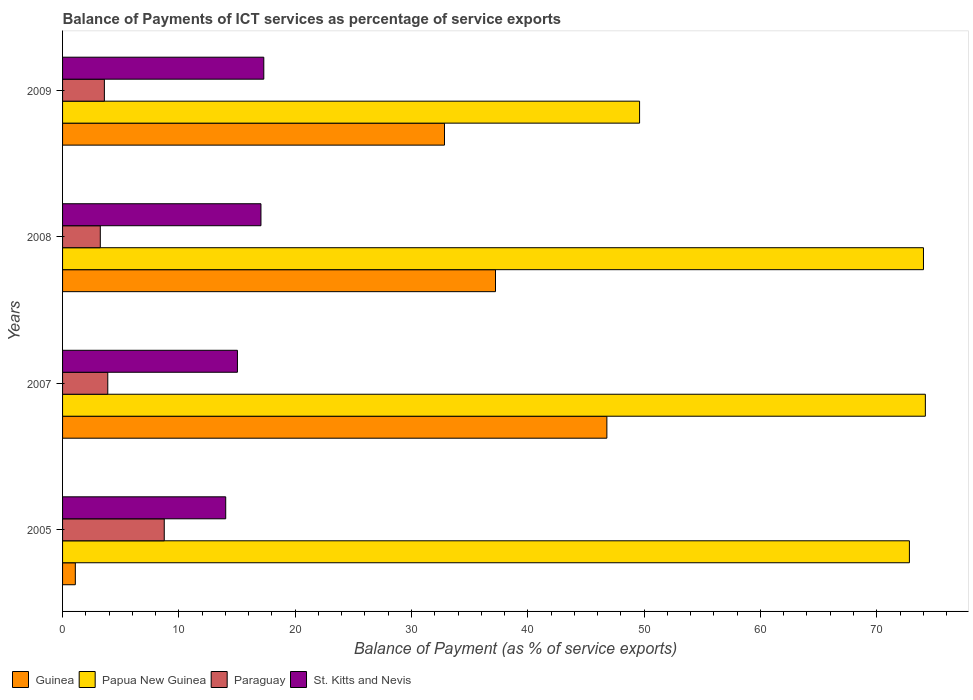How many groups of bars are there?
Your response must be concise. 4. Are the number of bars per tick equal to the number of legend labels?
Your answer should be very brief. Yes. How many bars are there on the 3rd tick from the top?
Offer a very short reply. 4. What is the label of the 2nd group of bars from the top?
Your answer should be very brief. 2008. In how many cases, is the number of bars for a given year not equal to the number of legend labels?
Your answer should be very brief. 0. What is the balance of payments of ICT services in Paraguay in 2005?
Keep it short and to the point. 8.74. Across all years, what is the maximum balance of payments of ICT services in Guinea?
Your answer should be very brief. 46.8. Across all years, what is the minimum balance of payments of ICT services in Paraguay?
Your answer should be compact. 3.24. In which year was the balance of payments of ICT services in Paraguay minimum?
Provide a succinct answer. 2008. What is the total balance of payments of ICT services in Papua New Guinea in the graph?
Make the answer very short. 270.61. What is the difference between the balance of payments of ICT services in Paraguay in 2008 and that in 2009?
Offer a terse response. -0.35. What is the difference between the balance of payments of ICT services in Papua New Guinea in 2005 and the balance of payments of ICT services in Guinea in 2009?
Keep it short and to the point. 39.97. What is the average balance of payments of ICT services in Paraguay per year?
Your answer should be compact. 4.87. In the year 2008, what is the difference between the balance of payments of ICT services in Guinea and balance of payments of ICT services in St. Kitts and Nevis?
Your answer should be very brief. 20.16. What is the ratio of the balance of payments of ICT services in Paraguay in 2008 to that in 2009?
Provide a succinct answer. 0.9. What is the difference between the highest and the second highest balance of payments of ICT services in Paraguay?
Your answer should be compact. 4.86. What is the difference between the highest and the lowest balance of payments of ICT services in St. Kitts and Nevis?
Keep it short and to the point. 3.27. What does the 3rd bar from the top in 2007 represents?
Keep it short and to the point. Papua New Guinea. What does the 2nd bar from the bottom in 2007 represents?
Your answer should be very brief. Papua New Guinea. How many bars are there?
Make the answer very short. 16. Are all the bars in the graph horizontal?
Offer a terse response. Yes. How many years are there in the graph?
Give a very brief answer. 4. Does the graph contain any zero values?
Give a very brief answer. No. How are the legend labels stacked?
Ensure brevity in your answer.  Horizontal. What is the title of the graph?
Your answer should be very brief. Balance of Payments of ICT services as percentage of service exports. Does "Saudi Arabia" appear as one of the legend labels in the graph?
Ensure brevity in your answer.  No. What is the label or title of the X-axis?
Offer a terse response. Balance of Payment (as % of service exports). What is the label or title of the Y-axis?
Keep it short and to the point. Years. What is the Balance of Payment (as % of service exports) of Guinea in 2005?
Give a very brief answer. 1.1. What is the Balance of Payment (as % of service exports) in Papua New Guinea in 2005?
Make the answer very short. 72.81. What is the Balance of Payment (as % of service exports) in Paraguay in 2005?
Keep it short and to the point. 8.74. What is the Balance of Payment (as % of service exports) of St. Kitts and Nevis in 2005?
Provide a succinct answer. 14.03. What is the Balance of Payment (as % of service exports) of Guinea in 2007?
Offer a very short reply. 46.8. What is the Balance of Payment (as % of service exports) in Papua New Guinea in 2007?
Keep it short and to the point. 74.18. What is the Balance of Payment (as % of service exports) in Paraguay in 2007?
Your answer should be very brief. 3.89. What is the Balance of Payment (as % of service exports) of St. Kitts and Nevis in 2007?
Your answer should be very brief. 15.03. What is the Balance of Payment (as % of service exports) of Guinea in 2008?
Give a very brief answer. 37.22. What is the Balance of Payment (as % of service exports) of Papua New Guinea in 2008?
Make the answer very short. 74.02. What is the Balance of Payment (as % of service exports) of Paraguay in 2008?
Make the answer very short. 3.24. What is the Balance of Payment (as % of service exports) in St. Kitts and Nevis in 2008?
Provide a succinct answer. 17.06. What is the Balance of Payment (as % of service exports) of Guinea in 2009?
Provide a succinct answer. 32.83. What is the Balance of Payment (as % of service exports) in Papua New Guinea in 2009?
Provide a short and direct response. 49.61. What is the Balance of Payment (as % of service exports) in Paraguay in 2009?
Keep it short and to the point. 3.59. What is the Balance of Payment (as % of service exports) of St. Kitts and Nevis in 2009?
Ensure brevity in your answer.  17.3. Across all years, what is the maximum Balance of Payment (as % of service exports) of Guinea?
Ensure brevity in your answer.  46.8. Across all years, what is the maximum Balance of Payment (as % of service exports) in Papua New Guinea?
Ensure brevity in your answer.  74.18. Across all years, what is the maximum Balance of Payment (as % of service exports) of Paraguay?
Provide a succinct answer. 8.74. Across all years, what is the maximum Balance of Payment (as % of service exports) in St. Kitts and Nevis?
Make the answer very short. 17.3. Across all years, what is the minimum Balance of Payment (as % of service exports) of Guinea?
Your answer should be compact. 1.1. Across all years, what is the minimum Balance of Payment (as % of service exports) of Papua New Guinea?
Offer a terse response. 49.61. Across all years, what is the minimum Balance of Payment (as % of service exports) in Paraguay?
Your response must be concise. 3.24. Across all years, what is the minimum Balance of Payment (as % of service exports) of St. Kitts and Nevis?
Offer a terse response. 14.03. What is the total Balance of Payment (as % of service exports) of Guinea in the graph?
Offer a terse response. 117.95. What is the total Balance of Payment (as % of service exports) of Papua New Guinea in the graph?
Keep it short and to the point. 270.61. What is the total Balance of Payment (as % of service exports) in Paraguay in the graph?
Provide a short and direct response. 19.47. What is the total Balance of Payment (as % of service exports) of St. Kitts and Nevis in the graph?
Keep it short and to the point. 63.42. What is the difference between the Balance of Payment (as % of service exports) in Guinea in 2005 and that in 2007?
Ensure brevity in your answer.  -45.7. What is the difference between the Balance of Payment (as % of service exports) in Papua New Guinea in 2005 and that in 2007?
Keep it short and to the point. -1.37. What is the difference between the Balance of Payment (as % of service exports) in Paraguay in 2005 and that in 2007?
Keep it short and to the point. 4.86. What is the difference between the Balance of Payment (as % of service exports) of St. Kitts and Nevis in 2005 and that in 2007?
Make the answer very short. -1.01. What is the difference between the Balance of Payment (as % of service exports) in Guinea in 2005 and that in 2008?
Offer a terse response. -36.12. What is the difference between the Balance of Payment (as % of service exports) in Papua New Guinea in 2005 and that in 2008?
Ensure brevity in your answer.  -1.21. What is the difference between the Balance of Payment (as % of service exports) of Paraguay in 2005 and that in 2008?
Offer a terse response. 5.5. What is the difference between the Balance of Payment (as % of service exports) of St. Kitts and Nevis in 2005 and that in 2008?
Offer a very short reply. -3.03. What is the difference between the Balance of Payment (as % of service exports) in Guinea in 2005 and that in 2009?
Your response must be concise. -31.74. What is the difference between the Balance of Payment (as % of service exports) of Papua New Guinea in 2005 and that in 2009?
Give a very brief answer. 23.2. What is the difference between the Balance of Payment (as % of service exports) of Paraguay in 2005 and that in 2009?
Your answer should be very brief. 5.15. What is the difference between the Balance of Payment (as % of service exports) of St. Kitts and Nevis in 2005 and that in 2009?
Offer a terse response. -3.27. What is the difference between the Balance of Payment (as % of service exports) in Guinea in 2007 and that in 2008?
Give a very brief answer. 9.58. What is the difference between the Balance of Payment (as % of service exports) in Papua New Guinea in 2007 and that in 2008?
Your answer should be very brief. 0.16. What is the difference between the Balance of Payment (as % of service exports) in Paraguay in 2007 and that in 2008?
Keep it short and to the point. 0.64. What is the difference between the Balance of Payment (as % of service exports) of St. Kitts and Nevis in 2007 and that in 2008?
Ensure brevity in your answer.  -2.02. What is the difference between the Balance of Payment (as % of service exports) of Guinea in 2007 and that in 2009?
Offer a terse response. 13.96. What is the difference between the Balance of Payment (as % of service exports) of Papua New Guinea in 2007 and that in 2009?
Your answer should be compact. 24.57. What is the difference between the Balance of Payment (as % of service exports) of Paraguay in 2007 and that in 2009?
Ensure brevity in your answer.  0.29. What is the difference between the Balance of Payment (as % of service exports) in St. Kitts and Nevis in 2007 and that in 2009?
Keep it short and to the point. -2.27. What is the difference between the Balance of Payment (as % of service exports) of Guinea in 2008 and that in 2009?
Ensure brevity in your answer.  4.39. What is the difference between the Balance of Payment (as % of service exports) in Papua New Guinea in 2008 and that in 2009?
Keep it short and to the point. 24.41. What is the difference between the Balance of Payment (as % of service exports) of Paraguay in 2008 and that in 2009?
Offer a terse response. -0.35. What is the difference between the Balance of Payment (as % of service exports) of St. Kitts and Nevis in 2008 and that in 2009?
Make the answer very short. -0.24. What is the difference between the Balance of Payment (as % of service exports) in Guinea in 2005 and the Balance of Payment (as % of service exports) in Papua New Guinea in 2007?
Your answer should be very brief. -73.08. What is the difference between the Balance of Payment (as % of service exports) of Guinea in 2005 and the Balance of Payment (as % of service exports) of Paraguay in 2007?
Offer a terse response. -2.79. What is the difference between the Balance of Payment (as % of service exports) in Guinea in 2005 and the Balance of Payment (as % of service exports) in St. Kitts and Nevis in 2007?
Provide a short and direct response. -13.94. What is the difference between the Balance of Payment (as % of service exports) of Papua New Guinea in 2005 and the Balance of Payment (as % of service exports) of Paraguay in 2007?
Provide a short and direct response. 68.92. What is the difference between the Balance of Payment (as % of service exports) of Papua New Guinea in 2005 and the Balance of Payment (as % of service exports) of St. Kitts and Nevis in 2007?
Provide a succinct answer. 57.77. What is the difference between the Balance of Payment (as % of service exports) of Paraguay in 2005 and the Balance of Payment (as % of service exports) of St. Kitts and Nevis in 2007?
Make the answer very short. -6.29. What is the difference between the Balance of Payment (as % of service exports) in Guinea in 2005 and the Balance of Payment (as % of service exports) in Papua New Guinea in 2008?
Provide a succinct answer. -72.92. What is the difference between the Balance of Payment (as % of service exports) in Guinea in 2005 and the Balance of Payment (as % of service exports) in Paraguay in 2008?
Make the answer very short. -2.15. What is the difference between the Balance of Payment (as % of service exports) in Guinea in 2005 and the Balance of Payment (as % of service exports) in St. Kitts and Nevis in 2008?
Give a very brief answer. -15.96. What is the difference between the Balance of Payment (as % of service exports) in Papua New Guinea in 2005 and the Balance of Payment (as % of service exports) in Paraguay in 2008?
Offer a very short reply. 69.56. What is the difference between the Balance of Payment (as % of service exports) of Papua New Guinea in 2005 and the Balance of Payment (as % of service exports) of St. Kitts and Nevis in 2008?
Provide a succinct answer. 55.75. What is the difference between the Balance of Payment (as % of service exports) in Paraguay in 2005 and the Balance of Payment (as % of service exports) in St. Kitts and Nevis in 2008?
Your answer should be compact. -8.31. What is the difference between the Balance of Payment (as % of service exports) of Guinea in 2005 and the Balance of Payment (as % of service exports) of Papua New Guinea in 2009?
Provide a succinct answer. -48.51. What is the difference between the Balance of Payment (as % of service exports) of Guinea in 2005 and the Balance of Payment (as % of service exports) of Paraguay in 2009?
Keep it short and to the point. -2.5. What is the difference between the Balance of Payment (as % of service exports) in Guinea in 2005 and the Balance of Payment (as % of service exports) in St. Kitts and Nevis in 2009?
Make the answer very short. -16.2. What is the difference between the Balance of Payment (as % of service exports) of Papua New Guinea in 2005 and the Balance of Payment (as % of service exports) of Paraguay in 2009?
Make the answer very short. 69.21. What is the difference between the Balance of Payment (as % of service exports) in Papua New Guinea in 2005 and the Balance of Payment (as % of service exports) in St. Kitts and Nevis in 2009?
Ensure brevity in your answer.  55.5. What is the difference between the Balance of Payment (as % of service exports) in Paraguay in 2005 and the Balance of Payment (as % of service exports) in St. Kitts and Nevis in 2009?
Give a very brief answer. -8.56. What is the difference between the Balance of Payment (as % of service exports) of Guinea in 2007 and the Balance of Payment (as % of service exports) of Papua New Guinea in 2008?
Provide a succinct answer. -27.22. What is the difference between the Balance of Payment (as % of service exports) of Guinea in 2007 and the Balance of Payment (as % of service exports) of Paraguay in 2008?
Keep it short and to the point. 43.55. What is the difference between the Balance of Payment (as % of service exports) in Guinea in 2007 and the Balance of Payment (as % of service exports) in St. Kitts and Nevis in 2008?
Your response must be concise. 29.74. What is the difference between the Balance of Payment (as % of service exports) of Papua New Guinea in 2007 and the Balance of Payment (as % of service exports) of Paraguay in 2008?
Offer a very short reply. 70.93. What is the difference between the Balance of Payment (as % of service exports) of Papua New Guinea in 2007 and the Balance of Payment (as % of service exports) of St. Kitts and Nevis in 2008?
Give a very brief answer. 57.12. What is the difference between the Balance of Payment (as % of service exports) in Paraguay in 2007 and the Balance of Payment (as % of service exports) in St. Kitts and Nevis in 2008?
Your response must be concise. -13.17. What is the difference between the Balance of Payment (as % of service exports) in Guinea in 2007 and the Balance of Payment (as % of service exports) in Papua New Guinea in 2009?
Provide a succinct answer. -2.81. What is the difference between the Balance of Payment (as % of service exports) of Guinea in 2007 and the Balance of Payment (as % of service exports) of Paraguay in 2009?
Ensure brevity in your answer.  43.2. What is the difference between the Balance of Payment (as % of service exports) in Guinea in 2007 and the Balance of Payment (as % of service exports) in St. Kitts and Nevis in 2009?
Offer a terse response. 29.5. What is the difference between the Balance of Payment (as % of service exports) of Papua New Guinea in 2007 and the Balance of Payment (as % of service exports) of Paraguay in 2009?
Your answer should be very brief. 70.58. What is the difference between the Balance of Payment (as % of service exports) of Papua New Guinea in 2007 and the Balance of Payment (as % of service exports) of St. Kitts and Nevis in 2009?
Give a very brief answer. 56.88. What is the difference between the Balance of Payment (as % of service exports) in Paraguay in 2007 and the Balance of Payment (as % of service exports) in St. Kitts and Nevis in 2009?
Make the answer very short. -13.41. What is the difference between the Balance of Payment (as % of service exports) of Guinea in 2008 and the Balance of Payment (as % of service exports) of Papua New Guinea in 2009?
Ensure brevity in your answer.  -12.39. What is the difference between the Balance of Payment (as % of service exports) in Guinea in 2008 and the Balance of Payment (as % of service exports) in Paraguay in 2009?
Your response must be concise. 33.63. What is the difference between the Balance of Payment (as % of service exports) of Guinea in 2008 and the Balance of Payment (as % of service exports) of St. Kitts and Nevis in 2009?
Give a very brief answer. 19.92. What is the difference between the Balance of Payment (as % of service exports) of Papua New Guinea in 2008 and the Balance of Payment (as % of service exports) of Paraguay in 2009?
Offer a terse response. 70.42. What is the difference between the Balance of Payment (as % of service exports) in Papua New Guinea in 2008 and the Balance of Payment (as % of service exports) in St. Kitts and Nevis in 2009?
Your answer should be compact. 56.71. What is the difference between the Balance of Payment (as % of service exports) of Paraguay in 2008 and the Balance of Payment (as % of service exports) of St. Kitts and Nevis in 2009?
Ensure brevity in your answer.  -14.06. What is the average Balance of Payment (as % of service exports) of Guinea per year?
Provide a succinct answer. 29.49. What is the average Balance of Payment (as % of service exports) of Papua New Guinea per year?
Offer a very short reply. 67.65. What is the average Balance of Payment (as % of service exports) in Paraguay per year?
Offer a very short reply. 4.87. What is the average Balance of Payment (as % of service exports) of St. Kitts and Nevis per year?
Your answer should be very brief. 15.85. In the year 2005, what is the difference between the Balance of Payment (as % of service exports) in Guinea and Balance of Payment (as % of service exports) in Papua New Guinea?
Provide a succinct answer. -71.71. In the year 2005, what is the difference between the Balance of Payment (as % of service exports) of Guinea and Balance of Payment (as % of service exports) of Paraguay?
Give a very brief answer. -7.64. In the year 2005, what is the difference between the Balance of Payment (as % of service exports) of Guinea and Balance of Payment (as % of service exports) of St. Kitts and Nevis?
Provide a succinct answer. -12.93. In the year 2005, what is the difference between the Balance of Payment (as % of service exports) of Papua New Guinea and Balance of Payment (as % of service exports) of Paraguay?
Provide a short and direct response. 64.06. In the year 2005, what is the difference between the Balance of Payment (as % of service exports) of Papua New Guinea and Balance of Payment (as % of service exports) of St. Kitts and Nevis?
Make the answer very short. 58.78. In the year 2005, what is the difference between the Balance of Payment (as % of service exports) of Paraguay and Balance of Payment (as % of service exports) of St. Kitts and Nevis?
Keep it short and to the point. -5.28. In the year 2007, what is the difference between the Balance of Payment (as % of service exports) in Guinea and Balance of Payment (as % of service exports) in Papua New Guinea?
Offer a very short reply. -27.38. In the year 2007, what is the difference between the Balance of Payment (as % of service exports) of Guinea and Balance of Payment (as % of service exports) of Paraguay?
Offer a terse response. 42.91. In the year 2007, what is the difference between the Balance of Payment (as % of service exports) of Guinea and Balance of Payment (as % of service exports) of St. Kitts and Nevis?
Provide a succinct answer. 31.76. In the year 2007, what is the difference between the Balance of Payment (as % of service exports) in Papua New Guinea and Balance of Payment (as % of service exports) in Paraguay?
Your answer should be compact. 70.29. In the year 2007, what is the difference between the Balance of Payment (as % of service exports) in Papua New Guinea and Balance of Payment (as % of service exports) in St. Kitts and Nevis?
Give a very brief answer. 59.14. In the year 2007, what is the difference between the Balance of Payment (as % of service exports) of Paraguay and Balance of Payment (as % of service exports) of St. Kitts and Nevis?
Offer a very short reply. -11.15. In the year 2008, what is the difference between the Balance of Payment (as % of service exports) of Guinea and Balance of Payment (as % of service exports) of Papua New Guinea?
Your response must be concise. -36.8. In the year 2008, what is the difference between the Balance of Payment (as % of service exports) in Guinea and Balance of Payment (as % of service exports) in Paraguay?
Ensure brevity in your answer.  33.98. In the year 2008, what is the difference between the Balance of Payment (as % of service exports) in Guinea and Balance of Payment (as % of service exports) in St. Kitts and Nevis?
Provide a short and direct response. 20.16. In the year 2008, what is the difference between the Balance of Payment (as % of service exports) in Papua New Guinea and Balance of Payment (as % of service exports) in Paraguay?
Offer a terse response. 70.77. In the year 2008, what is the difference between the Balance of Payment (as % of service exports) in Papua New Guinea and Balance of Payment (as % of service exports) in St. Kitts and Nevis?
Your answer should be very brief. 56.96. In the year 2008, what is the difference between the Balance of Payment (as % of service exports) of Paraguay and Balance of Payment (as % of service exports) of St. Kitts and Nevis?
Provide a short and direct response. -13.81. In the year 2009, what is the difference between the Balance of Payment (as % of service exports) in Guinea and Balance of Payment (as % of service exports) in Papua New Guinea?
Give a very brief answer. -16.77. In the year 2009, what is the difference between the Balance of Payment (as % of service exports) in Guinea and Balance of Payment (as % of service exports) in Paraguay?
Offer a terse response. 29.24. In the year 2009, what is the difference between the Balance of Payment (as % of service exports) of Guinea and Balance of Payment (as % of service exports) of St. Kitts and Nevis?
Keep it short and to the point. 15.53. In the year 2009, what is the difference between the Balance of Payment (as % of service exports) of Papua New Guinea and Balance of Payment (as % of service exports) of Paraguay?
Give a very brief answer. 46.01. In the year 2009, what is the difference between the Balance of Payment (as % of service exports) of Papua New Guinea and Balance of Payment (as % of service exports) of St. Kitts and Nevis?
Offer a very short reply. 32.31. In the year 2009, what is the difference between the Balance of Payment (as % of service exports) in Paraguay and Balance of Payment (as % of service exports) in St. Kitts and Nevis?
Offer a very short reply. -13.71. What is the ratio of the Balance of Payment (as % of service exports) of Guinea in 2005 to that in 2007?
Provide a succinct answer. 0.02. What is the ratio of the Balance of Payment (as % of service exports) in Papua New Guinea in 2005 to that in 2007?
Keep it short and to the point. 0.98. What is the ratio of the Balance of Payment (as % of service exports) in Paraguay in 2005 to that in 2007?
Your response must be concise. 2.25. What is the ratio of the Balance of Payment (as % of service exports) in St. Kitts and Nevis in 2005 to that in 2007?
Ensure brevity in your answer.  0.93. What is the ratio of the Balance of Payment (as % of service exports) in Guinea in 2005 to that in 2008?
Your answer should be compact. 0.03. What is the ratio of the Balance of Payment (as % of service exports) of Papua New Guinea in 2005 to that in 2008?
Give a very brief answer. 0.98. What is the ratio of the Balance of Payment (as % of service exports) in Paraguay in 2005 to that in 2008?
Provide a succinct answer. 2.69. What is the ratio of the Balance of Payment (as % of service exports) in St. Kitts and Nevis in 2005 to that in 2008?
Give a very brief answer. 0.82. What is the ratio of the Balance of Payment (as % of service exports) of Guinea in 2005 to that in 2009?
Your response must be concise. 0.03. What is the ratio of the Balance of Payment (as % of service exports) of Papua New Guinea in 2005 to that in 2009?
Give a very brief answer. 1.47. What is the ratio of the Balance of Payment (as % of service exports) in Paraguay in 2005 to that in 2009?
Ensure brevity in your answer.  2.43. What is the ratio of the Balance of Payment (as % of service exports) in St. Kitts and Nevis in 2005 to that in 2009?
Ensure brevity in your answer.  0.81. What is the ratio of the Balance of Payment (as % of service exports) of Guinea in 2007 to that in 2008?
Provide a succinct answer. 1.26. What is the ratio of the Balance of Payment (as % of service exports) of Paraguay in 2007 to that in 2008?
Keep it short and to the point. 1.2. What is the ratio of the Balance of Payment (as % of service exports) in St. Kitts and Nevis in 2007 to that in 2008?
Offer a very short reply. 0.88. What is the ratio of the Balance of Payment (as % of service exports) in Guinea in 2007 to that in 2009?
Provide a succinct answer. 1.43. What is the ratio of the Balance of Payment (as % of service exports) in Papua New Guinea in 2007 to that in 2009?
Your response must be concise. 1.5. What is the ratio of the Balance of Payment (as % of service exports) of Paraguay in 2007 to that in 2009?
Provide a succinct answer. 1.08. What is the ratio of the Balance of Payment (as % of service exports) in St. Kitts and Nevis in 2007 to that in 2009?
Keep it short and to the point. 0.87. What is the ratio of the Balance of Payment (as % of service exports) of Guinea in 2008 to that in 2009?
Provide a short and direct response. 1.13. What is the ratio of the Balance of Payment (as % of service exports) of Papua New Guinea in 2008 to that in 2009?
Your response must be concise. 1.49. What is the ratio of the Balance of Payment (as % of service exports) in Paraguay in 2008 to that in 2009?
Offer a terse response. 0.9. What is the ratio of the Balance of Payment (as % of service exports) of St. Kitts and Nevis in 2008 to that in 2009?
Offer a terse response. 0.99. What is the difference between the highest and the second highest Balance of Payment (as % of service exports) in Guinea?
Offer a very short reply. 9.58. What is the difference between the highest and the second highest Balance of Payment (as % of service exports) of Papua New Guinea?
Provide a succinct answer. 0.16. What is the difference between the highest and the second highest Balance of Payment (as % of service exports) of Paraguay?
Your response must be concise. 4.86. What is the difference between the highest and the second highest Balance of Payment (as % of service exports) in St. Kitts and Nevis?
Your answer should be compact. 0.24. What is the difference between the highest and the lowest Balance of Payment (as % of service exports) of Guinea?
Provide a short and direct response. 45.7. What is the difference between the highest and the lowest Balance of Payment (as % of service exports) of Papua New Guinea?
Provide a succinct answer. 24.57. What is the difference between the highest and the lowest Balance of Payment (as % of service exports) of Paraguay?
Your answer should be very brief. 5.5. What is the difference between the highest and the lowest Balance of Payment (as % of service exports) in St. Kitts and Nevis?
Keep it short and to the point. 3.27. 